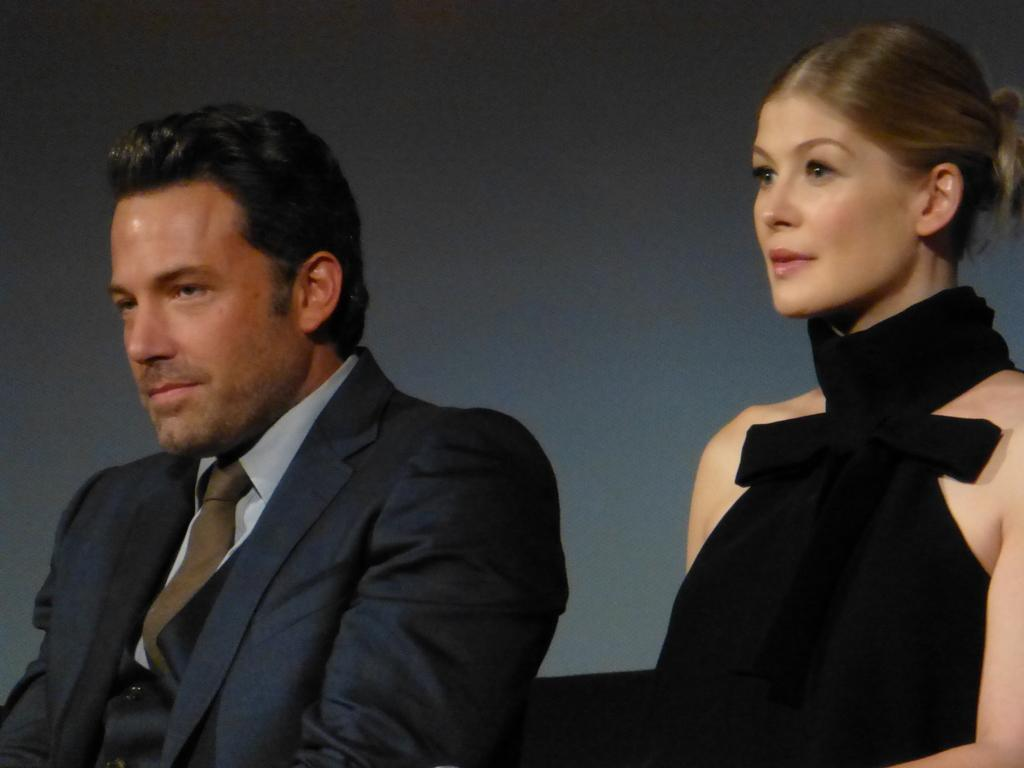What is the main subject in the foreground of the picture? There is a person in a blue suit and a woman in a black dress in the foreground of the picture. Can you describe the position of the person in the blue suit? The person in the blue suit is on the left side of the image. How about the woman in the black dress? The woman in the black dress is on the right side of the image. What type of cord is being used to connect the sun to the base in the image? There is no sun, base, or cord present in the image. 